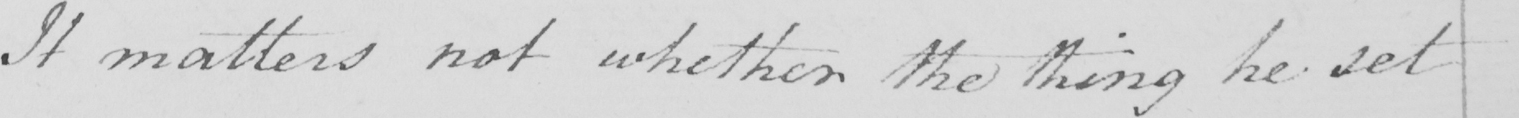What is written in this line of handwriting? It matters not whether the thing be set 